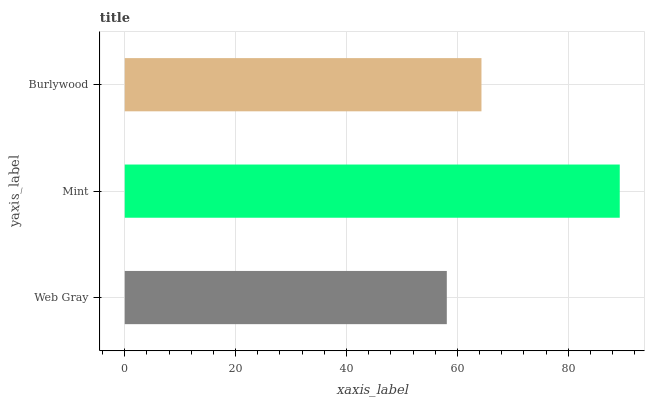Is Web Gray the minimum?
Answer yes or no. Yes. Is Mint the maximum?
Answer yes or no. Yes. Is Burlywood the minimum?
Answer yes or no. No. Is Burlywood the maximum?
Answer yes or no. No. Is Mint greater than Burlywood?
Answer yes or no. Yes. Is Burlywood less than Mint?
Answer yes or no. Yes. Is Burlywood greater than Mint?
Answer yes or no. No. Is Mint less than Burlywood?
Answer yes or no. No. Is Burlywood the high median?
Answer yes or no. Yes. Is Burlywood the low median?
Answer yes or no. Yes. Is Mint the high median?
Answer yes or no. No. Is Mint the low median?
Answer yes or no. No. 